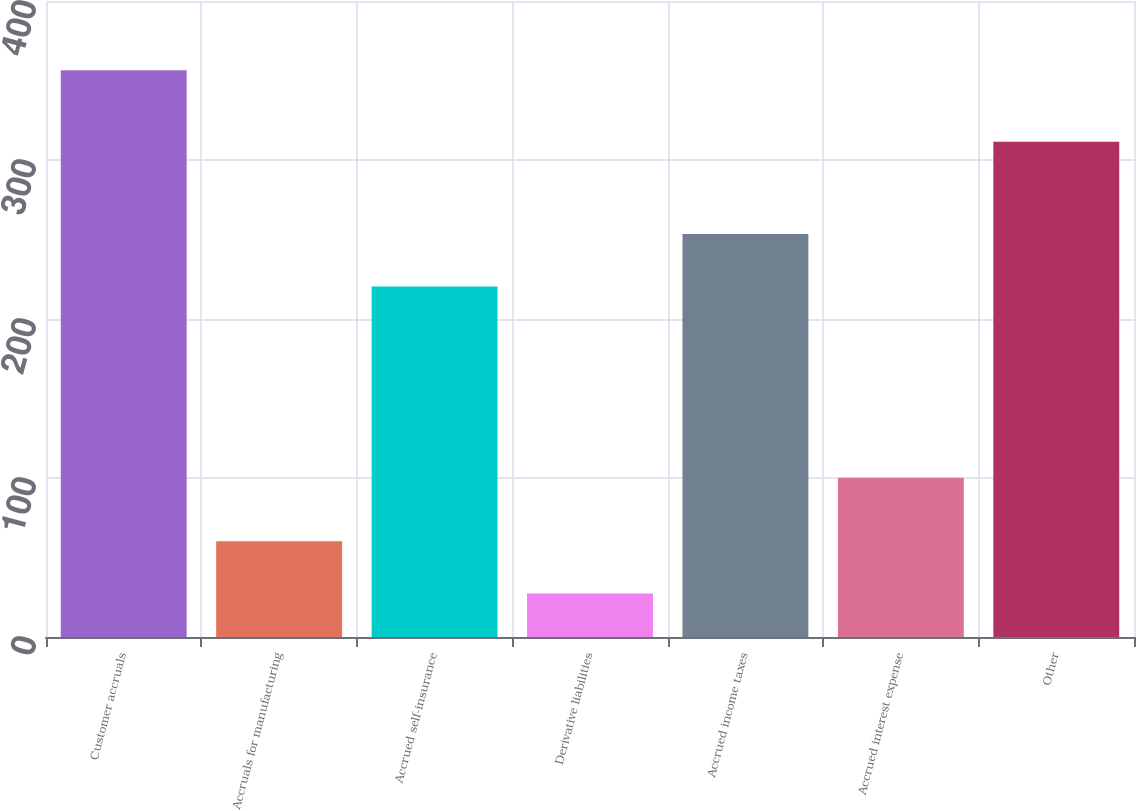Convert chart to OTSL. <chart><loc_0><loc_0><loc_500><loc_500><bar_chart><fcel>Customer accruals<fcel>Accruals for manufacturing<fcel>Accrued self-insurance<fcel>Derivative liabilities<fcel>Accrued income taxes<fcel>Accrued interest expense<fcel>Other<nl><fcel>356.5<fcel>60.22<fcel>220.5<fcel>27.3<fcel>253.42<fcel>100.1<fcel>311.5<nl></chart> 